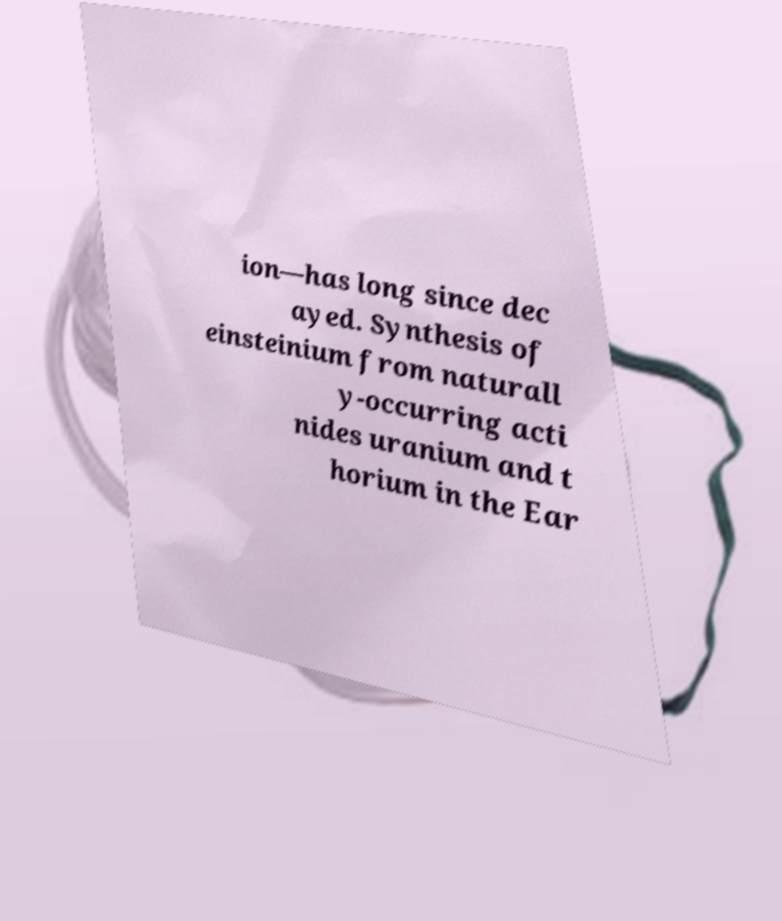Could you assist in decoding the text presented in this image and type it out clearly? ion—has long since dec ayed. Synthesis of einsteinium from naturall y-occurring acti nides uranium and t horium in the Ear 